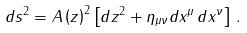<formula> <loc_0><loc_0><loc_500><loc_500>d s ^ { 2 } = A \left ( z \right ) ^ { 2 } \left [ d z ^ { 2 } + \eta _ { \mu \nu } d x ^ { \mu } \, d x ^ { \nu } \right ] \, .</formula> 